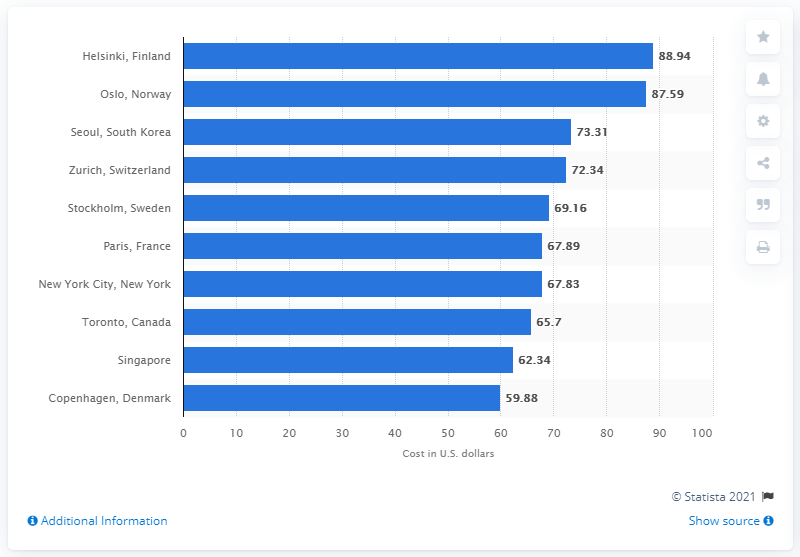Outline some significant characteristics in this image. In 2014, the average cost of a room in Helsinki was 88.94. 